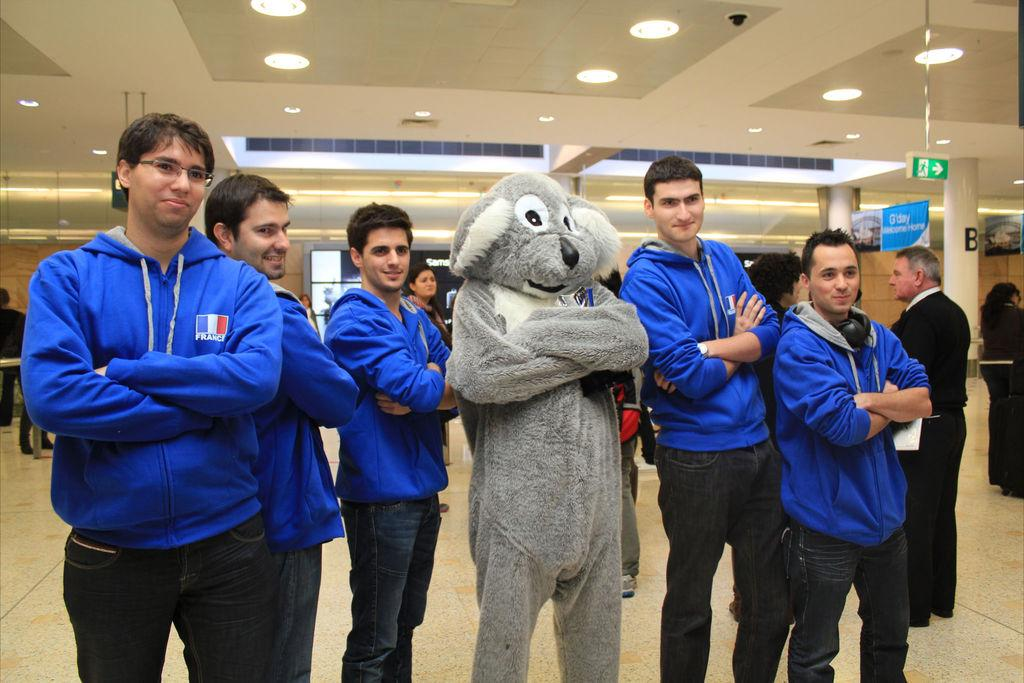What can be observed about the people in the image? There are people standing in the image. Can you describe the setting of the image? There are people in the background of the image, and there are lights visible in the image. What additional features can be seen in the image? Banners and pillars are visible in the image. Are there any other objects present in the image? Signboards are present in the image. What types of toys can be seen on the table during the meeting in the image? There is no meeting or table with toys present in the image. 